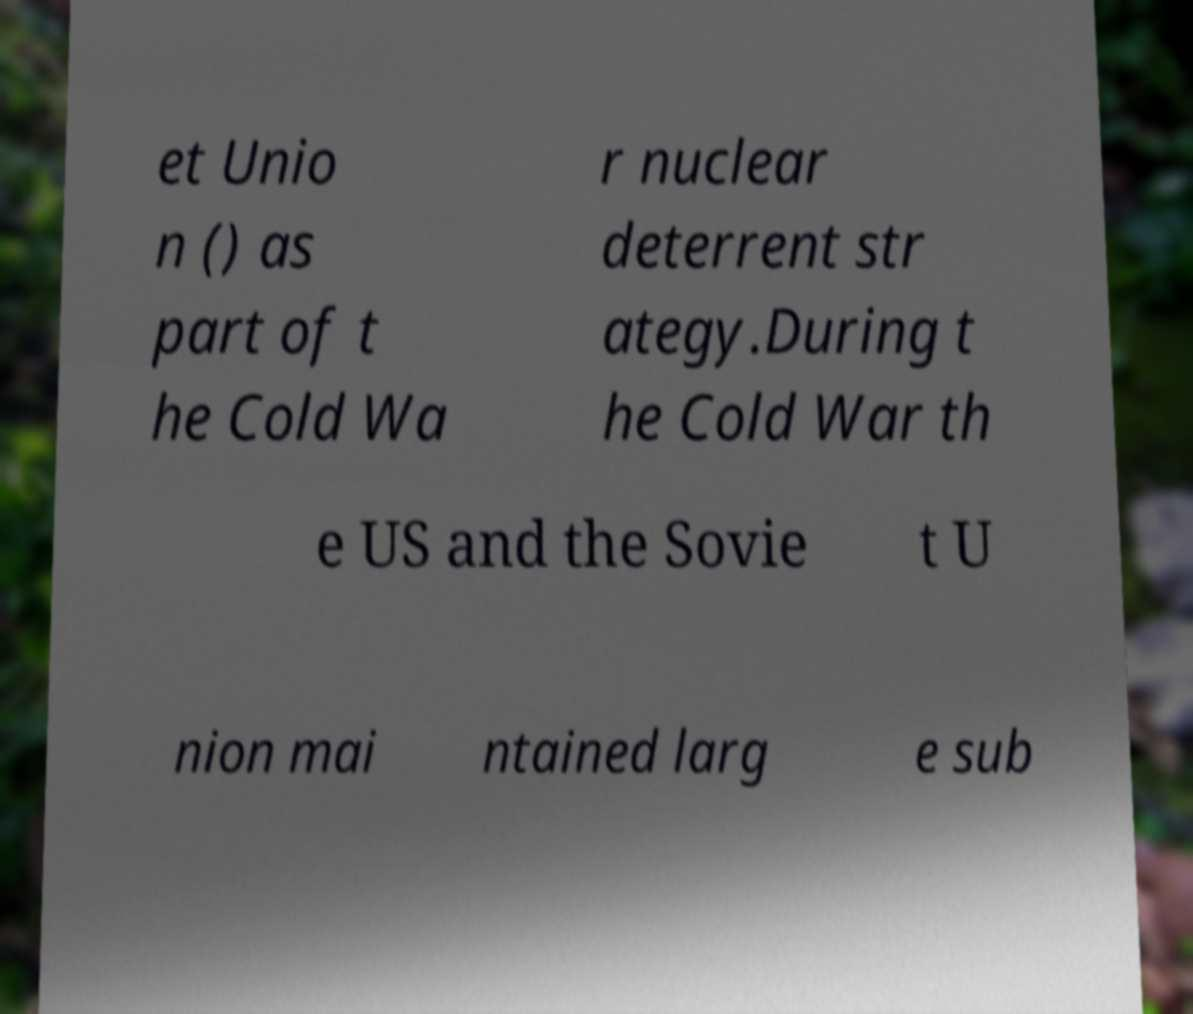Can you accurately transcribe the text from the provided image for me? et Unio n () as part of t he Cold Wa r nuclear deterrent str ategy.During t he Cold War th e US and the Sovie t U nion mai ntained larg e sub 